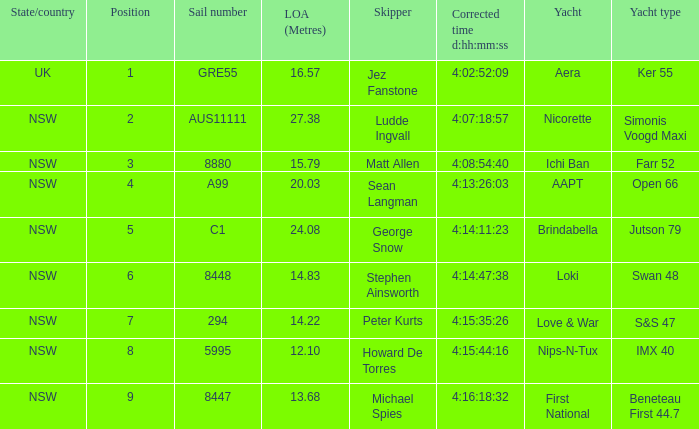What is the placement for nsw open 66 racing ship? 4.0. 